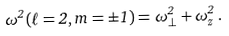<formula> <loc_0><loc_0><loc_500><loc_500>\omega ^ { 2 } ( \ell = 2 , m = \pm 1 ) = \omega _ { \perp } ^ { 2 } + \omega _ { z } ^ { 2 } \, .</formula> 